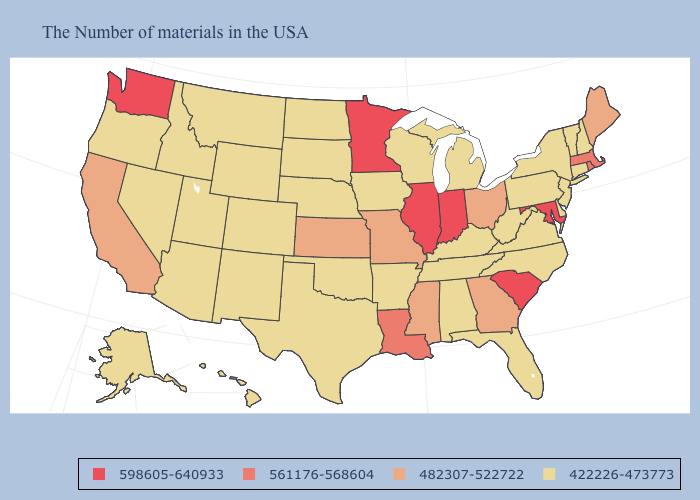Does Massachusetts have a higher value than South Carolina?
Give a very brief answer. No. What is the highest value in the USA?
Keep it brief. 598605-640933. Name the states that have a value in the range 561176-568604?
Concise answer only. Massachusetts, Rhode Island, Louisiana. Name the states that have a value in the range 598605-640933?
Quick response, please. Maryland, South Carolina, Indiana, Illinois, Minnesota, Washington. Which states have the lowest value in the South?
Short answer required. Delaware, Virginia, North Carolina, West Virginia, Florida, Kentucky, Alabama, Tennessee, Arkansas, Oklahoma, Texas. Among the states that border New York , does New Jersey have the lowest value?
Answer briefly. Yes. What is the value of Pennsylvania?
Keep it brief. 422226-473773. Among the states that border Virginia , does Maryland have the lowest value?
Answer briefly. No. Name the states that have a value in the range 598605-640933?
Be succinct. Maryland, South Carolina, Indiana, Illinois, Minnesota, Washington. What is the value of Nebraska?
Give a very brief answer. 422226-473773. Which states hav the highest value in the Northeast?
Answer briefly. Massachusetts, Rhode Island. What is the value of Indiana?
Give a very brief answer. 598605-640933. What is the highest value in the MidWest ?
Short answer required. 598605-640933. Name the states that have a value in the range 482307-522722?
Give a very brief answer. Maine, Ohio, Georgia, Mississippi, Missouri, Kansas, California. Name the states that have a value in the range 561176-568604?
Give a very brief answer. Massachusetts, Rhode Island, Louisiana. 